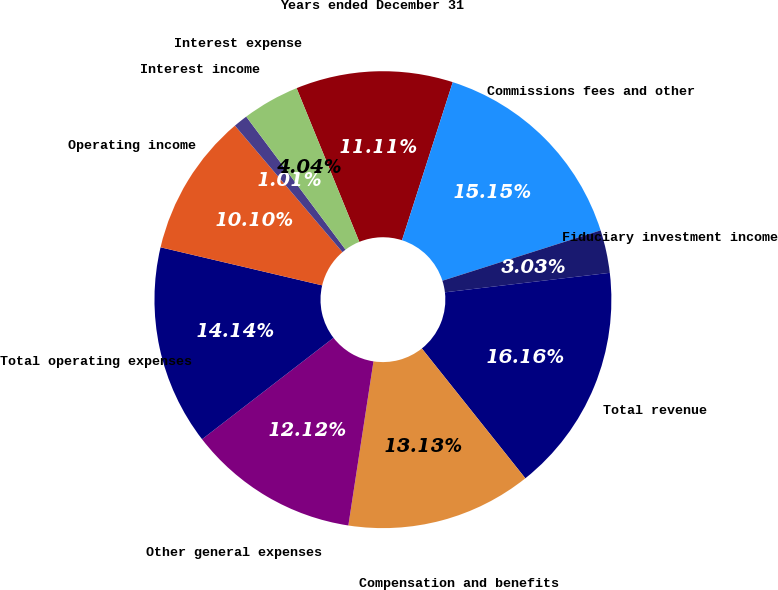Convert chart. <chart><loc_0><loc_0><loc_500><loc_500><pie_chart><fcel>Years ended December 31<fcel>Commissions fees and other<fcel>Fiduciary investment income<fcel>Total revenue<fcel>Compensation and benefits<fcel>Other general expenses<fcel>Total operating expenses<fcel>Operating income<fcel>Interest income<fcel>Interest expense<nl><fcel>11.11%<fcel>15.15%<fcel>3.03%<fcel>16.16%<fcel>13.13%<fcel>12.12%<fcel>14.14%<fcel>10.1%<fcel>1.01%<fcel>4.04%<nl></chart> 